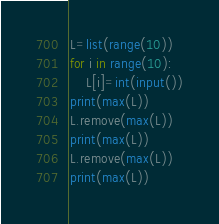Convert code to text. <code><loc_0><loc_0><loc_500><loc_500><_Python_>L=list(range(10))
for i in range(10):
    L[i]=int(input())
print(max(L))
L.remove(max(L))
print(max(L))
L.remove(max(L))
print(max(L))</code> 